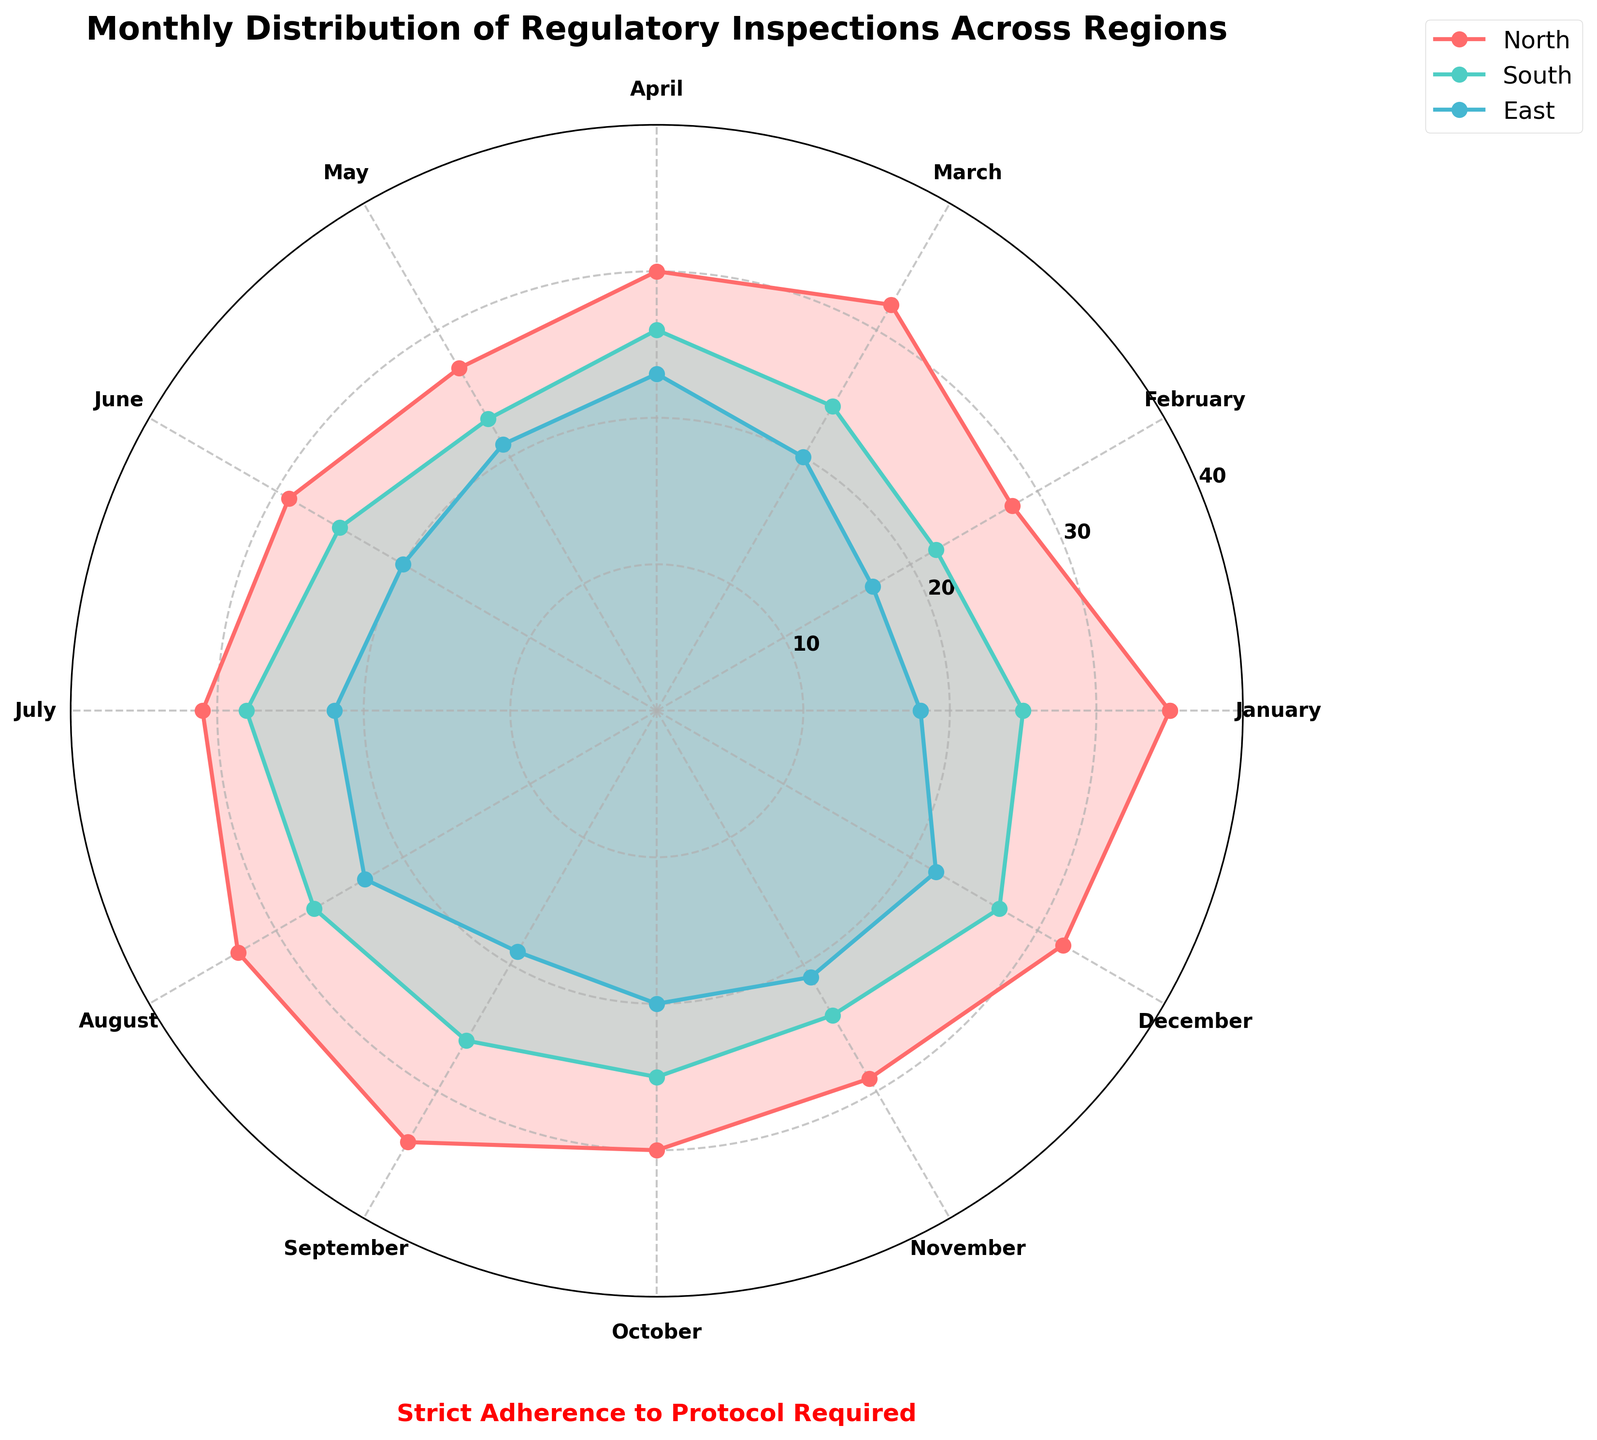What is the title of the figure? The title is located at the top of the figure and reads "Monthly Distribution of Regulatory Inspections Across Regions".
Answer: Monthly Distribution of Regulatory Inspections Across Regions Which region has the highest number of inspections in December? By looking at the data points in December on the rose chart, the region with the highest value is identified. The value for each region in December is as follows: North - 32, South - 27, East - 22, West - 33. The West has the highest value.
Answer: West How many months does the North region have more than 30 inspections? Count the months where the North region's data points are above the 30-mark on the y-axis. The months are January, March, July, August, and September, totaling 5.
Answer: 5 Compare the total number of inspections in August for North and South regions. Which one is higher? Check the data points for North and South regions in August. North has 33 inspections, while South has 27 inspections. Comparing these values, North has more inspections.
Answer: North What's the difference in the number of inspections between the West and East regions in March? From the plot, find the values for the West and East regions in March. West has 29 inspections, East has 20 inspections. Calculate the difference: 29 - 20 = 9.
Answer: 9 Which month shows the lowest number of inspections for the East region? Check the values for each month within the East region's line. February (17 inspections) is the lowest.
Answer: February For the North region, what is the range (difference between the maximum and minimum) of inspections throughout the year? Identify the highest and lowest inspection values for the North region. The highest is September (34) and the lowest is May (27), so the range is 34 - 27 = 7.
Answer: 7 Compare the average number of inspections for the North and South regions in the first quarter (January, February, March). Which region has higher average inspections? Calculate the average for January, February, and March for both regions. North: (35 + 28 + 32) / 3 = 31.67; South: (25 + 22 + 24) / 3 = 23.67. North has a higher average.
Answer: North Does the West region have more inspections in June or in September? Check the data points for the West region in both June (30) and September (31). Comparing these values, West has more inspections in September.
Answer: September How many regions have a number of inspections greater than 30 in July? Identify the values for July in each region. North has 31, South has 28, East has 22, West has 33. Both North and West regions have more than 30 inspections, totaling 2 regions.
Answer: 2 